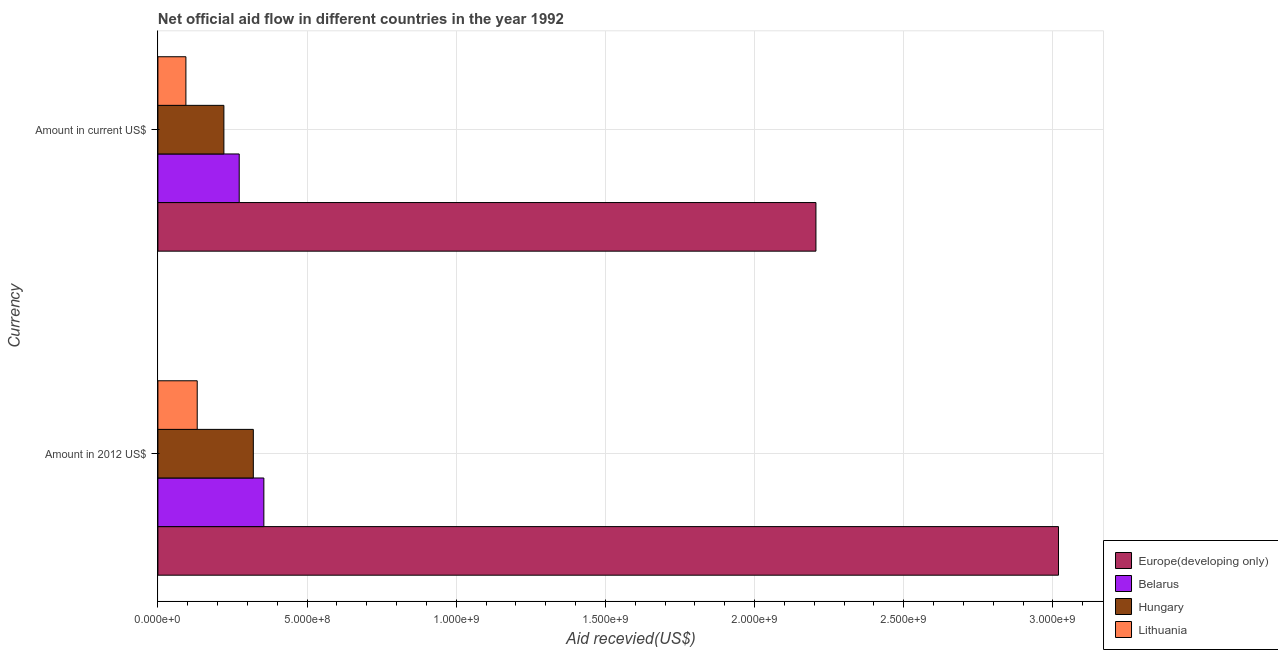How many different coloured bars are there?
Ensure brevity in your answer.  4. Are the number of bars on each tick of the Y-axis equal?
Provide a short and direct response. Yes. How many bars are there on the 1st tick from the top?
Give a very brief answer. 4. How many bars are there on the 1st tick from the bottom?
Give a very brief answer. 4. What is the label of the 2nd group of bars from the top?
Your answer should be compact. Amount in 2012 US$. What is the amount of aid received(expressed in us$) in Lithuania?
Offer a very short reply. 9.38e+07. Across all countries, what is the maximum amount of aid received(expressed in 2012 us$)?
Make the answer very short. 3.02e+09. Across all countries, what is the minimum amount of aid received(expressed in us$)?
Give a very brief answer. 9.38e+07. In which country was the amount of aid received(expressed in us$) maximum?
Your answer should be very brief. Europe(developing only). In which country was the amount of aid received(expressed in 2012 us$) minimum?
Give a very brief answer. Lithuania. What is the total amount of aid received(expressed in us$) in the graph?
Offer a terse response. 2.79e+09. What is the difference between the amount of aid received(expressed in 2012 us$) in Belarus and that in Hungary?
Offer a very short reply. 3.53e+07. What is the difference between the amount of aid received(expressed in us$) in Hungary and the amount of aid received(expressed in 2012 us$) in Europe(developing only)?
Give a very brief answer. -2.80e+09. What is the average amount of aid received(expressed in 2012 us$) per country?
Your answer should be compact. 9.56e+08. What is the difference between the amount of aid received(expressed in us$) and amount of aid received(expressed in 2012 us$) in Hungary?
Provide a short and direct response. -9.87e+07. In how many countries, is the amount of aid received(expressed in 2012 us$) greater than 1300000000 US$?
Offer a very short reply. 1. What is the ratio of the amount of aid received(expressed in us$) in Hungary to that in Lithuania?
Offer a terse response. 2.36. In how many countries, is the amount of aid received(expressed in 2012 us$) greater than the average amount of aid received(expressed in 2012 us$) taken over all countries?
Keep it short and to the point. 1. What does the 2nd bar from the top in Amount in current US$ represents?
Provide a succinct answer. Hungary. What does the 3rd bar from the bottom in Amount in current US$ represents?
Your answer should be compact. Hungary. Are all the bars in the graph horizontal?
Keep it short and to the point. Yes. How many countries are there in the graph?
Offer a terse response. 4. Does the graph contain any zero values?
Keep it short and to the point. No. Does the graph contain grids?
Provide a succinct answer. Yes. How many legend labels are there?
Make the answer very short. 4. What is the title of the graph?
Give a very brief answer. Net official aid flow in different countries in the year 1992. What is the label or title of the X-axis?
Provide a short and direct response. Aid recevied(US$). What is the label or title of the Y-axis?
Keep it short and to the point. Currency. What is the Aid recevied(US$) in Europe(developing only) in Amount in 2012 US$?
Your answer should be compact. 3.02e+09. What is the Aid recevied(US$) of Belarus in Amount in 2012 US$?
Offer a very short reply. 3.55e+08. What is the Aid recevied(US$) in Hungary in Amount in 2012 US$?
Keep it short and to the point. 3.20e+08. What is the Aid recevied(US$) of Lithuania in Amount in 2012 US$?
Offer a very short reply. 1.32e+08. What is the Aid recevied(US$) in Europe(developing only) in Amount in current US$?
Provide a short and direct response. 2.21e+09. What is the Aid recevied(US$) in Belarus in Amount in current US$?
Your response must be concise. 2.73e+08. What is the Aid recevied(US$) in Hungary in Amount in current US$?
Your answer should be very brief. 2.21e+08. What is the Aid recevied(US$) of Lithuania in Amount in current US$?
Offer a terse response. 9.38e+07. Across all Currency, what is the maximum Aid recevied(US$) in Europe(developing only)?
Keep it short and to the point. 3.02e+09. Across all Currency, what is the maximum Aid recevied(US$) of Belarus?
Keep it short and to the point. 3.55e+08. Across all Currency, what is the maximum Aid recevied(US$) of Hungary?
Your answer should be compact. 3.20e+08. Across all Currency, what is the maximum Aid recevied(US$) in Lithuania?
Ensure brevity in your answer.  1.32e+08. Across all Currency, what is the minimum Aid recevied(US$) in Europe(developing only)?
Keep it short and to the point. 2.21e+09. Across all Currency, what is the minimum Aid recevied(US$) in Belarus?
Offer a very short reply. 2.73e+08. Across all Currency, what is the minimum Aid recevied(US$) in Hungary?
Ensure brevity in your answer.  2.21e+08. Across all Currency, what is the minimum Aid recevied(US$) of Lithuania?
Keep it short and to the point. 9.38e+07. What is the total Aid recevied(US$) of Europe(developing only) in the graph?
Give a very brief answer. 5.22e+09. What is the total Aid recevied(US$) in Belarus in the graph?
Offer a very short reply. 6.28e+08. What is the total Aid recevied(US$) of Hungary in the graph?
Keep it short and to the point. 5.41e+08. What is the total Aid recevied(US$) of Lithuania in the graph?
Your answer should be compact. 2.26e+08. What is the difference between the Aid recevied(US$) of Europe(developing only) in Amount in 2012 US$ and that in Amount in current US$?
Your answer should be compact. 8.13e+08. What is the difference between the Aid recevied(US$) of Belarus in Amount in 2012 US$ and that in Amount in current US$?
Give a very brief answer. 8.26e+07. What is the difference between the Aid recevied(US$) of Hungary in Amount in 2012 US$ and that in Amount in current US$?
Offer a very short reply. 9.87e+07. What is the difference between the Aid recevied(US$) of Lithuania in Amount in 2012 US$ and that in Amount in current US$?
Offer a terse response. 3.79e+07. What is the difference between the Aid recevied(US$) in Europe(developing only) in Amount in 2012 US$ and the Aid recevied(US$) in Belarus in Amount in current US$?
Offer a very short reply. 2.75e+09. What is the difference between the Aid recevied(US$) of Europe(developing only) in Amount in 2012 US$ and the Aid recevied(US$) of Hungary in Amount in current US$?
Provide a succinct answer. 2.80e+09. What is the difference between the Aid recevied(US$) in Europe(developing only) in Amount in 2012 US$ and the Aid recevied(US$) in Lithuania in Amount in current US$?
Keep it short and to the point. 2.92e+09. What is the difference between the Aid recevied(US$) of Belarus in Amount in 2012 US$ and the Aid recevied(US$) of Hungary in Amount in current US$?
Your answer should be very brief. 1.34e+08. What is the difference between the Aid recevied(US$) of Belarus in Amount in 2012 US$ and the Aid recevied(US$) of Lithuania in Amount in current US$?
Your response must be concise. 2.61e+08. What is the difference between the Aid recevied(US$) in Hungary in Amount in 2012 US$ and the Aid recevied(US$) in Lithuania in Amount in current US$?
Make the answer very short. 2.26e+08. What is the average Aid recevied(US$) in Europe(developing only) per Currency?
Keep it short and to the point. 2.61e+09. What is the average Aid recevied(US$) of Belarus per Currency?
Keep it short and to the point. 3.14e+08. What is the average Aid recevied(US$) of Hungary per Currency?
Ensure brevity in your answer.  2.70e+08. What is the average Aid recevied(US$) of Lithuania per Currency?
Keep it short and to the point. 1.13e+08. What is the difference between the Aid recevied(US$) of Europe(developing only) and Aid recevied(US$) of Belarus in Amount in 2012 US$?
Offer a terse response. 2.66e+09. What is the difference between the Aid recevied(US$) in Europe(developing only) and Aid recevied(US$) in Hungary in Amount in 2012 US$?
Ensure brevity in your answer.  2.70e+09. What is the difference between the Aid recevied(US$) in Europe(developing only) and Aid recevied(US$) in Lithuania in Amount in 2012 US$?
Keep it short and to the point. 2.89e+09. What is the difference between the Aid recevied(US$) of Belarus and Aid recevied(US$) of Hungary in Amount in 2012 US$?
Make the answer very short. 3.53e+07. What is the difference between the Aid recevied(US$) of Belarus and Aid recevied(US$) of Lithuania in Amount in 2012 US$?
Offer a terse response. 2.23e+08. What is the difference between the Aid recevied(US$) in Hungary and Aid recevied(US$) in Lithuania in Amount in 2012 US$?
Ensure brevity in your answer.  1.88e+08. What is the difference between the Aid recevied(US$) in Europe(developing only) and Aid recevied(US$) in Belarus in Amount in current US$?
Make the answer very short. 1.93e+09. What is the difference between the Aid recevied(US$) in Europe(developing only) and Aid recevied(US$) in Hungary in Amount in current US$?
Make the answer very short. 1.98e+09. What is the difference between the Aid recevied(US$) of Europe(developing only) and Aid recevied(US$) of Lithuania in Amount in current US$?
Your response must be concise. 2.11e+09. What is the difference between the Aid recevied(US$) of Belarus and Aid recevied(US$) of Hungary in Amount in current US$?
Offer a terse response. 5.14e+07. What is the difference between the Aid recevied(US$) in Belarus and Aid recevied(US$) in Lithuania in Amount in current US$?
Provide a succinct answer. 1.79e+08. What is the difference between the Aid recevied(US$) in Hungary and Aid recevied(US$) in Lithuania in Amount in current US$?
Your answer should be compact. 1.27e+08. What is the ratio of the Aid recevied(US$) in Europe(developing only) in Amount in 2012 US$ to that in Amount in current US$?
Offer a very short reply. 1.37. What is the ratio of the Aid recevied(US$) of Belarus in Amount in 2012 US$ to that in Amount in current US$?
Keep it short and to the point. 1.3. What is the ratio of the Aid recevied(US$) of Hungary in Amount in 2012 US$ to that in Amount in current US$?
Keep it short and to the point. 1.45. What is the ratio of the Aid recevied(US$) in Lithuania in Amount in 2012 US$ to that in Amount in current US$?
Ensure brevity in your answer.  1.4. What is the difference between the highest and the second highest Aid recevied(US$) of Europe(developing only)?
Provide a short and direct response. 8.13e+08. What is the difference between the highest and the second highest Aid recevied(US$) of Belarus?
Make the answer very short. 8.26e+07. What is the difference between the highest and the second highest Aid recevied(US$) in Hungary?
Your answer should be very brief. 9.87e+07. What is the difference between the highest and the second highest Aid recevied(US$) in Lithuania?
Your response must be concise. 3.79e+07. What is the difference between the highest and the lowest Aid recevied(US$) in Europe(developing only)?
Your answer should be compact. 8.13e+08. What is the difference between the highest and the lowest Aid recevied(US$) of Belarus?
Your response must be concise. 8.26e+07. What is the difference between the highest and the lowest Aid recevied(US$) in Hungary?
Offer a terse response. 9.87e+07. What is the difference between the highest and the lowest Aid recevied(US$) of Lithuania?
Offer a terse response. 3.79e+07. 